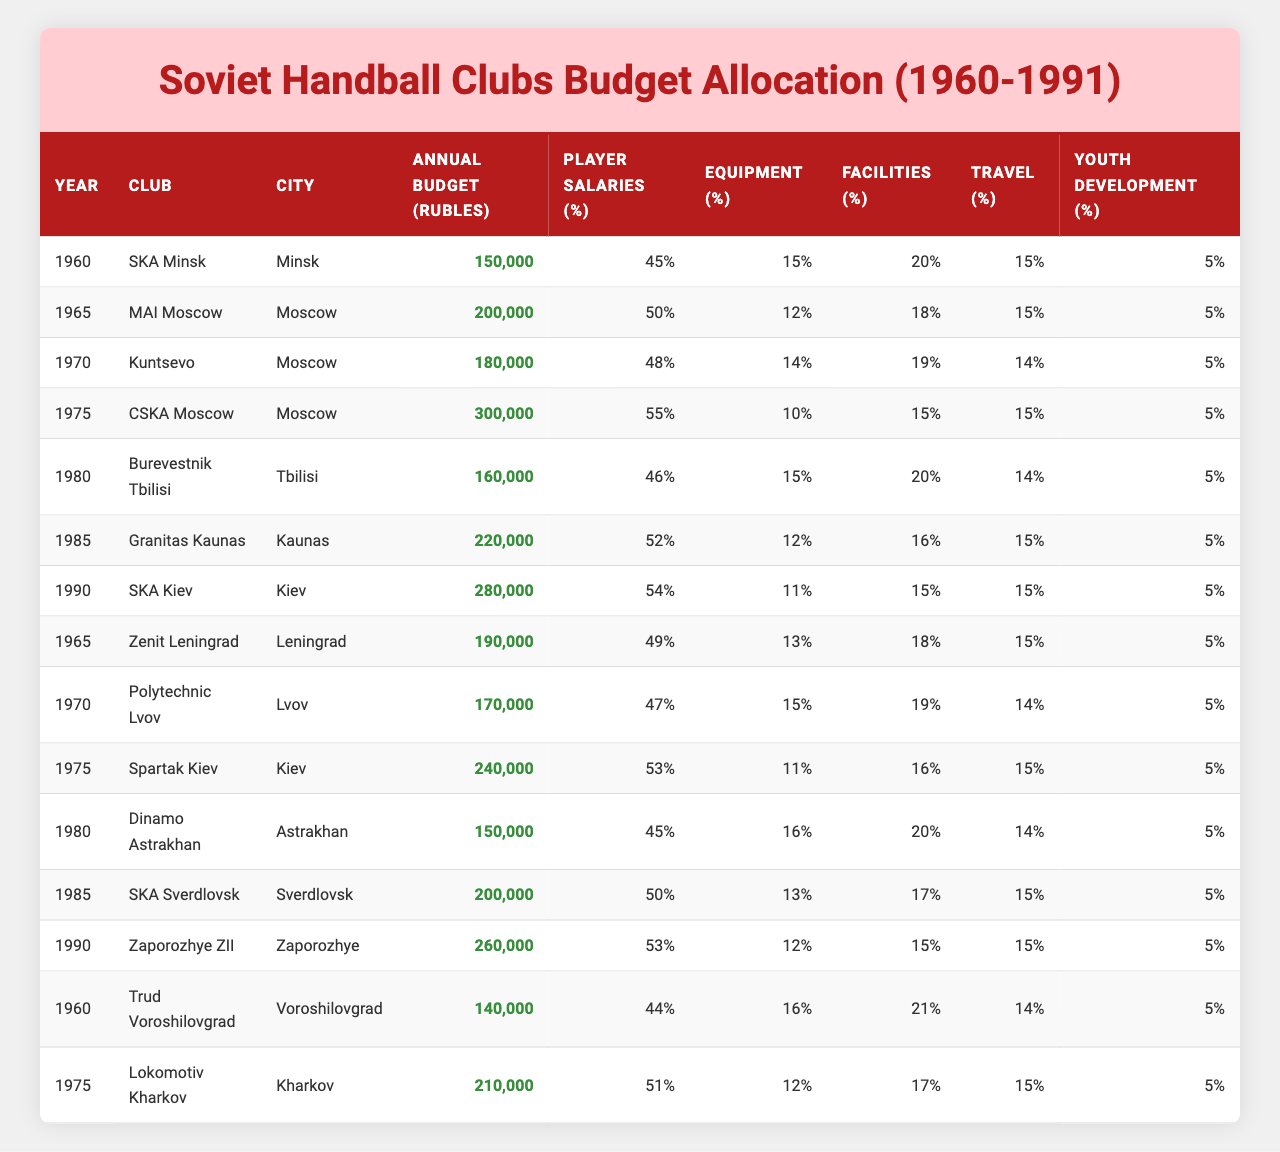What was the highest annual budget allocated to a handball club in 1990? In 1990, the club with the highest annual budget was SKA Kiev, which had a budget of 280,000 Rubles.
Answer: 280,000 Rubles Which club had the lowest budget in 1960? In 1960, Trud Voroshilovgrad had the lowest annual budget, which was 140,000 Rubles.
Answer: 140,000 Rubles What percentage of the budget for CSKA Moscow in 1975 was allocated to player salaries? In 1975, CSKA Moscow allocated 55% of its budget to player salaries.
Answer: 55% Which year saw an allocation of over 250,000 Rubles for a handball club? The year 1990 saw an allocation of over 250,000 Rubles, specifically 280,000 Rubles for SKA Kiev and 260,000 Rubles for Zaporozhye ZII.
Answer: Yes What is the average annual budget allocated to clubs in the 1980s (1980-1985)? The budgets for 1980 (160,000), 1985 (220,000), and 1985 (200,000) sum to 580,000. Dividing by 3 gives an average of 193,333.33 Rubles.
Answer: 193,333 Rubles Did Lokomotiv Kharkov have a higher budget than Burevestnik Tbilisi in 1975? Lokomotiv Kharkov had a budget of 210,000 Rubles compared to Burevestnik Tbilisi's 160,000 Rubles in the same year, indicating Lokomotiv Kharkov had a higher budget.
Answer: Yes What was the total percentage allocated to youth development across all clubs in the table? Each club allocated 5% to youth development, and there are 14 rows of data, leading to a total of 5% × 14 = 70%.
Answer: 70% In which city was the handball club with the second highest budget in 1985 located? In 1985, Granitas Kaunas had a budget of 220,000 Rubles, which was the second highest after the 240,000 Rubles of Spartak Kiev located in Kiev. Thus, Granitas Kaunas is in Kaunas.
Answer: Kaunas What was the total budget allocated to Kuntsevo and Polytechnic Lvov in 1970? Kuntsevo had a budget of 180,000 Rubles and Polytechnic Lvov had a budget of 170,000 Rubles. The total is 180,000 + 170,000 = 350,000 Rubles.
Answer: 350,000 Rubles Which club had the highest percentage allocation for travel in 1980? In 1980, Dinamo Astrakhan allocated 14% of its budget to travel, which was the highest percentage among clubs for that year.
Answer: 14% 